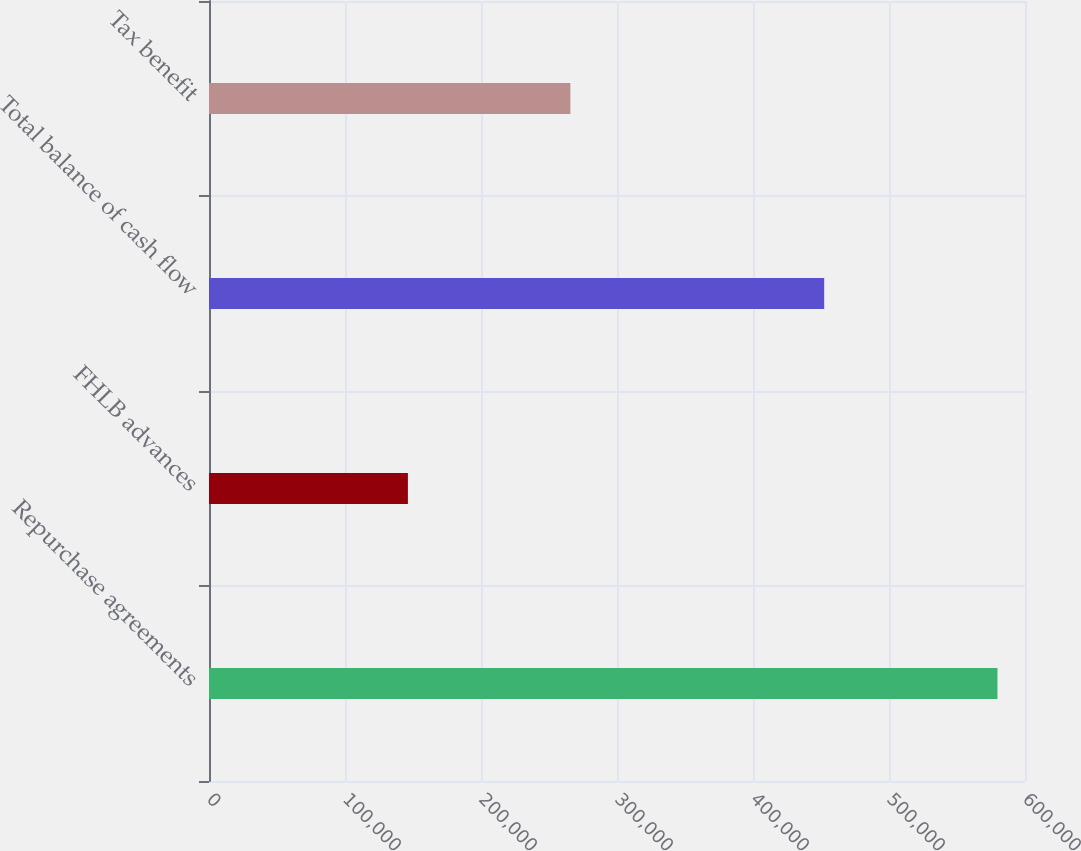<chart> <loc_0><loc_0><loc_500><loc_500><bar_chart><fcel>Repurchase agreements<fcel>FHLB advances<fcel>Total balance of cash flow<fcel>Tax benefit<nl><fcel>579763<fcel>146253<fcel>452341<fcel>265705<nl></chart> 